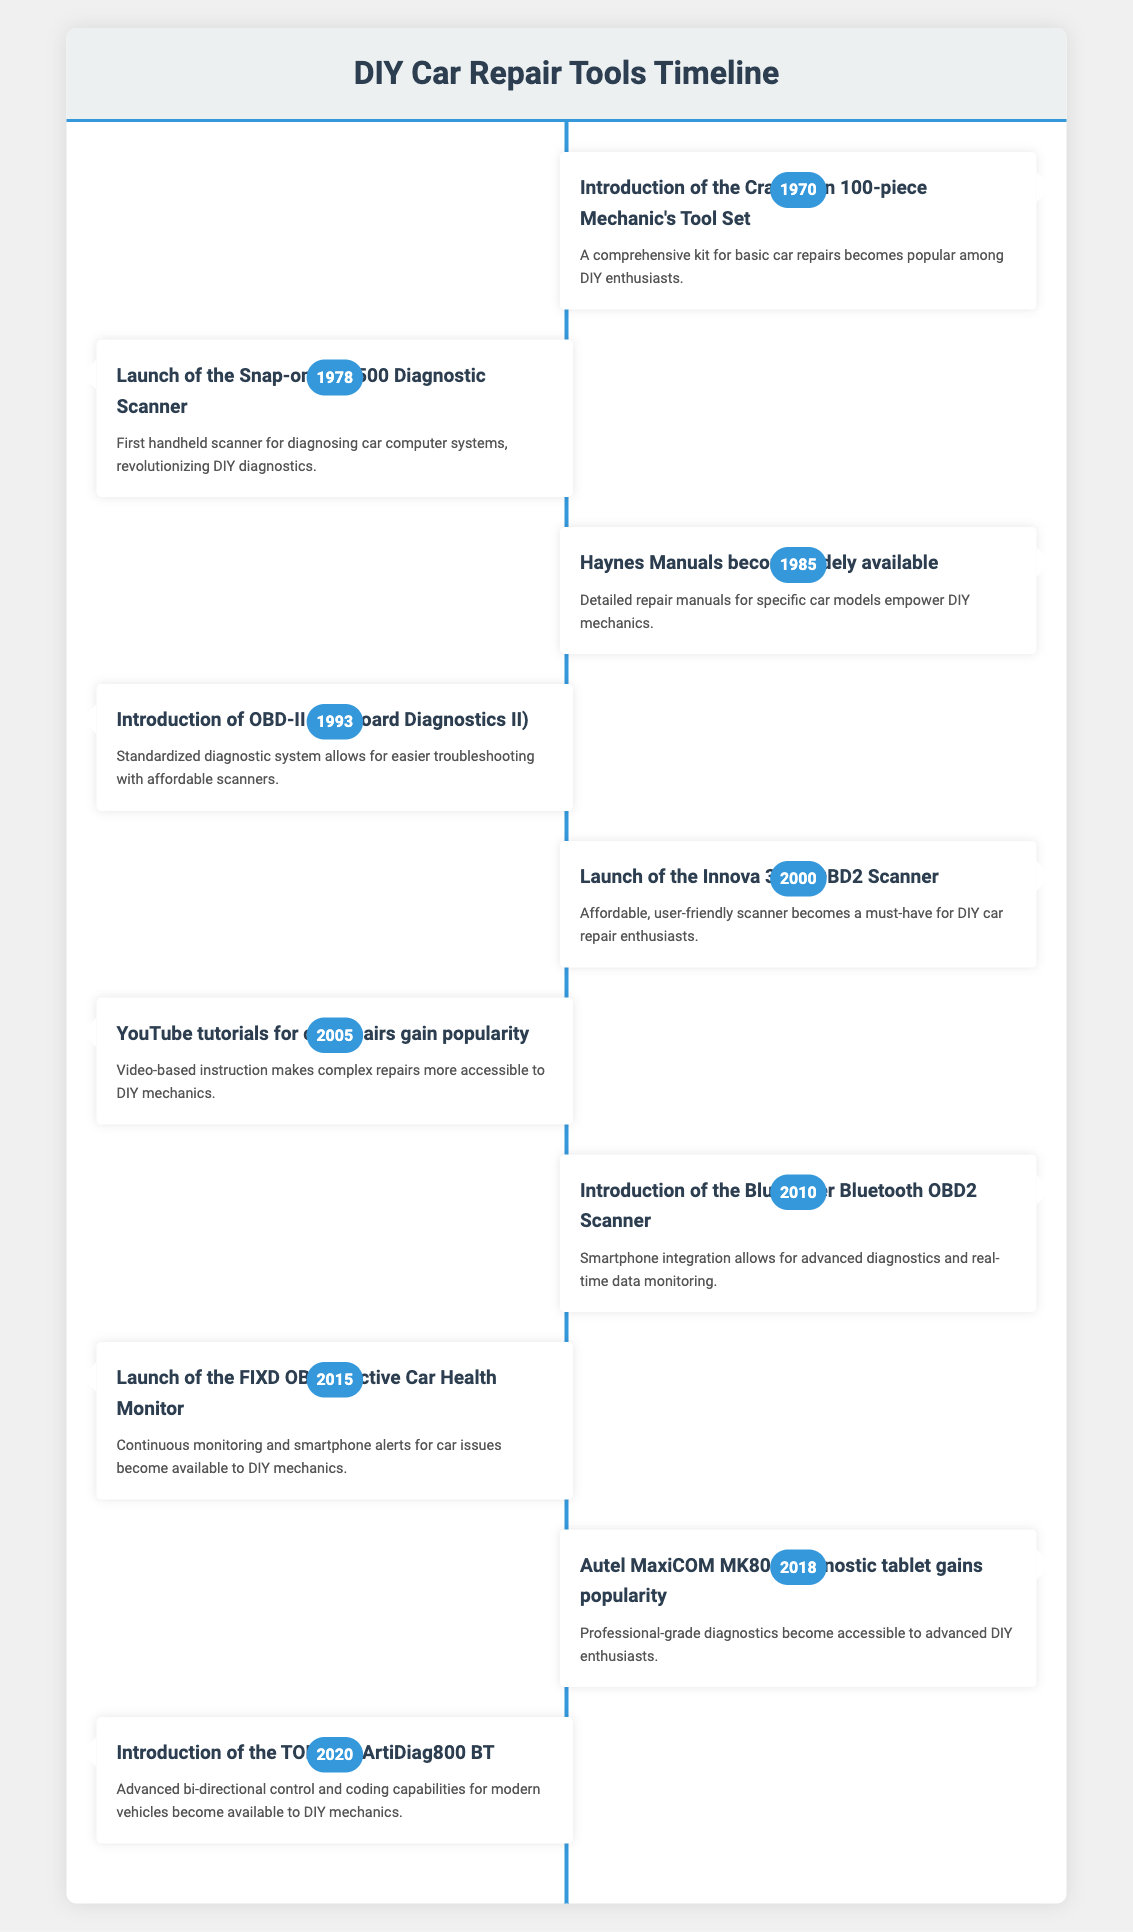What year did the Craftsman Tool Set become popular? The table indicates that the Craftsman 100-piece Mechanic's Tool Set was introduced in 1970. Therefore, 1970 is the year when this tool set became popular among DIY enthusiasts.
Answer: 1970 What tool was launched in 2005 that changed how DIY car repair enthusiasts learn new skills? According to the table, in 2005, YouTube tutorials for car repairs gained popularity, leading to an increase in accessible video-based instruction for DIY mechanics.
Answer: YouTube tutorials Which tool is noted for being the first handheld scanner for diagnosing car computer systems? The Snap-on MT2500 Diagnostic Scanner was launched in 1978, as mentioned in the table. It is recognized as the first handheld scanner for this purpose.
Answer: Snap-on MT2500 Diagnostic Scanner How many years passed between the introduction of the Craftsman Tool Set and the launch of the FIXD Car Health Monitor? The Craftsman Tool Set was introduced in 1970 and the FIXD OBD-II Active Car Health Monitor was launched in 2015. The time difference is 2015 - 1970 = 45 years.
Answer: 45 years Is it true that the BlueDriver Bluetooth OBD2 Scanner was introduced before the OBD-II standard was established? The table shows that OBD-II was introduced in 1993 and the BlueDriver was introduced in 2010. Since 2010 comes after 1993, the statement is false.
Answer: No What advancements in car diagnostic tools occurred between 2000 and 2010? From the timeline, the Innova 3100 OBD2 Scanner was launched in 2000, followed by the BlueDriver Bluetooth OBD2 Scanner in 2010. This suggests a progression towards more affordable, user-friendly technology integrating smartphone features for diagnostics.
Answer: Smartphone integration and affordability What was the significance of the OBD-II introduction in 1993 for DIY mechanics? The introduction of OBD-II standardized diagnostics, making it easier for DIY mechanics to troubleshoot vehicles using affordable scanners, as stated in the table. This was a significant advancement in car diagnostics.
Answer: Easier troubleshooting Which event introduced professional-grade diagnostics to advanced DIY enthusiasts in 2018? The Autel MaxiCOM MK808 diagnostic tablet gained popularity in 2018, providing advanced diagnostic features that were previously harder to access for DIY enthusiasts.
Answer: Autel MaxiCOM MK808 